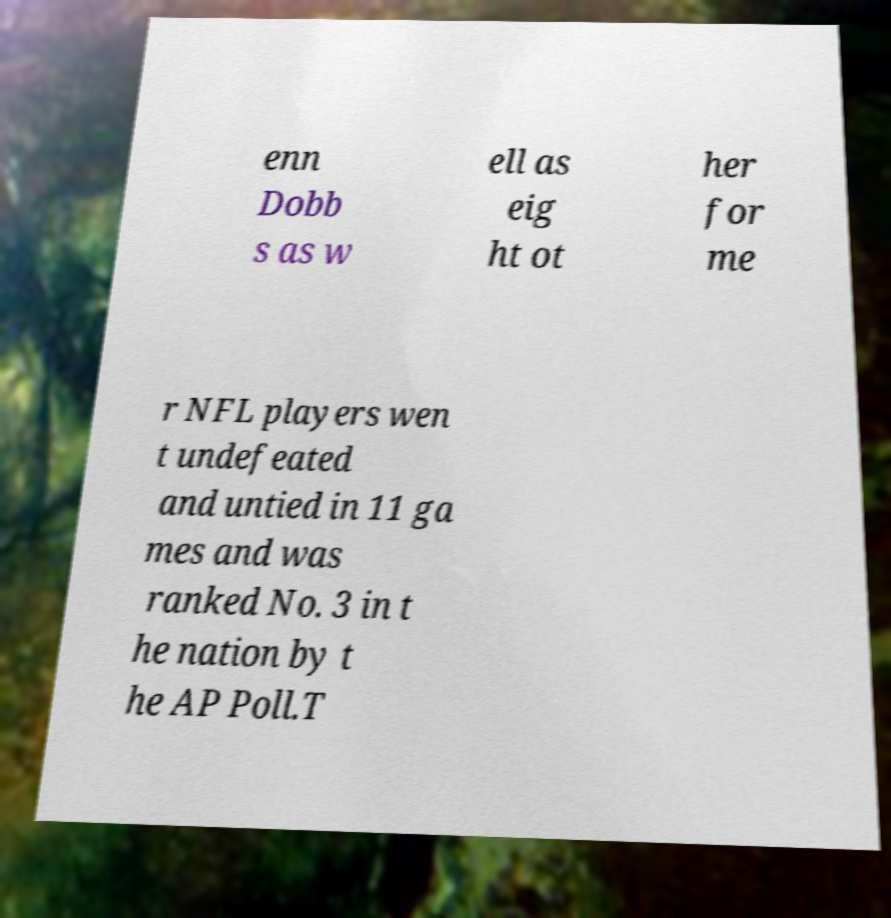Could you extract and type out the text from this image? enn Dobb s as w ell as eig ht ot her for me r NFL players wen t undefeated and untied in 11 ga mes and was ranked No. 3 in t he nation by t he AP Poll.T 